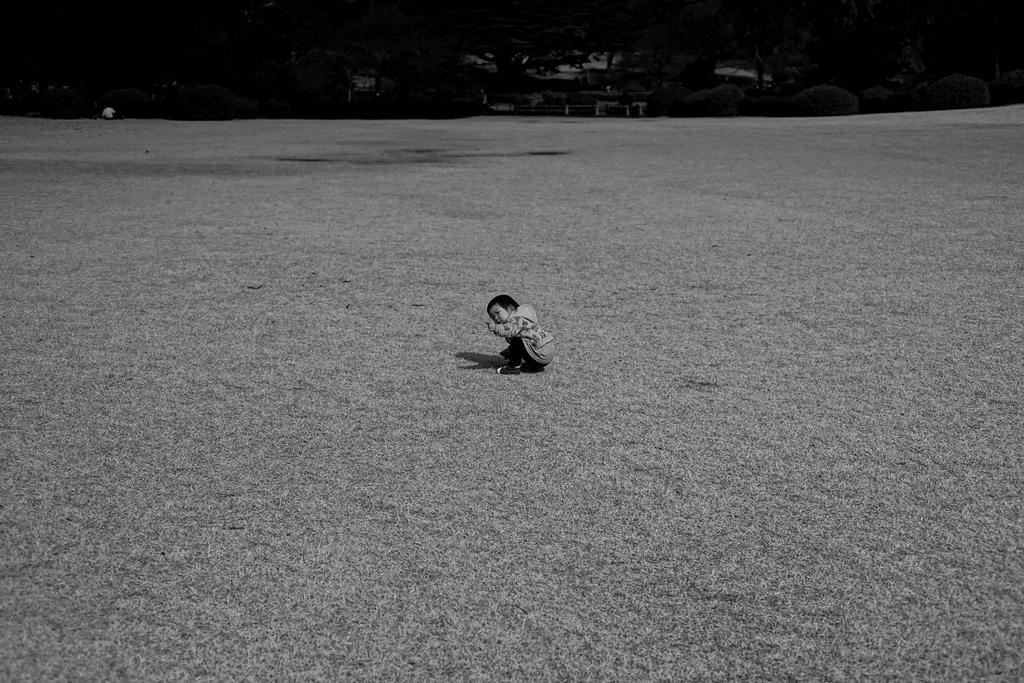Could you give a brief overview of what you see in this image? This is a black and white image where we can see a boy is sitting on the grassy land. In the background, we can see plants and trees. 